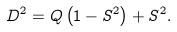Convert formula to latex. <formula><loc_0><loc_0><loc_500><loc_500>D ^ { 2 } = Q \left ( 1 - S ^ { 2 } \right ) + S ^ { 2 } .</formula> 